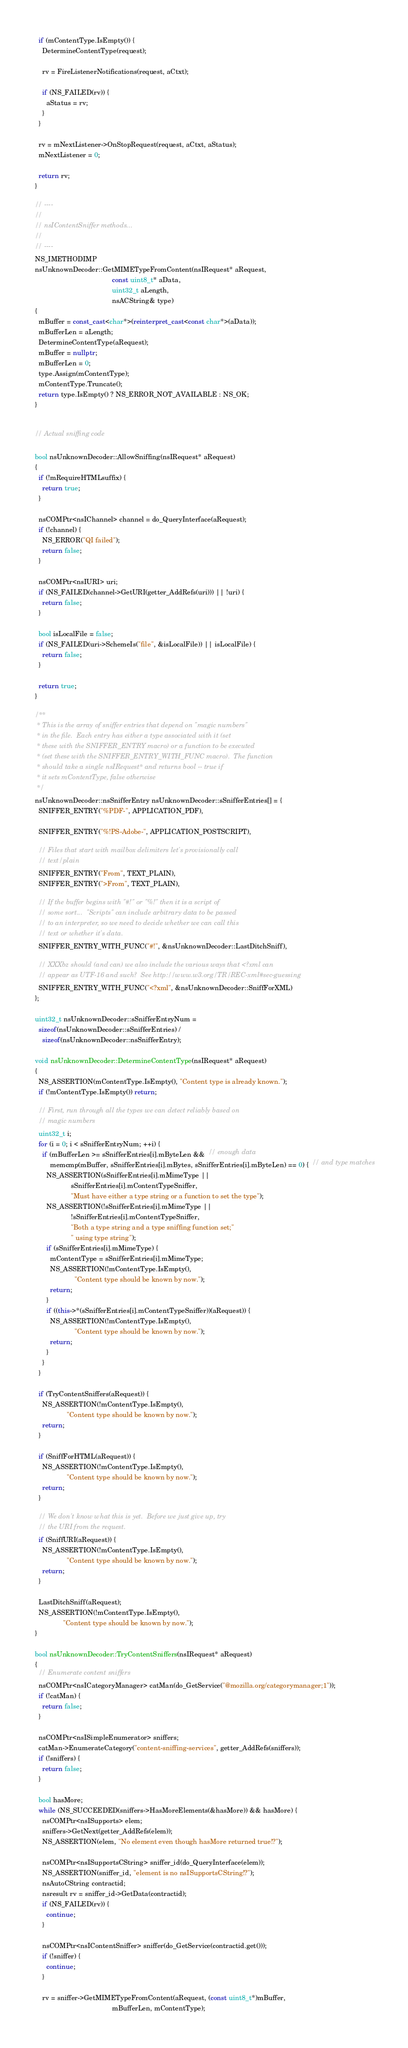<code> <loc_0><loc_0><loc_500><loc_500><_C++_>  if (mContentType.IsEmpty()) {
    DetermineContentType(request);

    rv = FireListenerNotifications(request, aCtxt);

    if (NS_FAILED(rv)) {
      aStatus = rv;
    }
  }

  rv = mNextListener->OnStopRequest(request, aCtxt, aStatus);
  mNextListener = 0;

  return rv;
}

// ----
//
// nsIContentSniffer methods...
//
// ----
NS_IMETHODIMP
nsUnknownDecoder::GetMIMETypeFromContent(nsIRequest* aRequest,
                                         const uint8_t* aData,
                                         uint32_t aLength,
                                         nsACString& type)
{
  mBuffer = const_cast<char*>(reinterpret_cast<const char*>(aData));
  mBufferLen = aLength;
  DetermineContentType(aRequest);
  mBuffer = nullptr;
  mBufferLen = 0;
  type.Assign(mContentType);
  mContentType.Truncate();
  return type.IsEmpty() ? NS_ERROR_NOT_AVAILABLE : NS_OK;
}


// Actual sniffing code

bool nsUnknownDecoder::AllowSniffing(nsIRequest* aRequest)
{
  if (!mRequireHTMLsuffix) {
    return true;
  }
  
  nsCOMPtr<nsIChannel> channel = do_QueryInterface(aRequest);
  if (!channel) {
    NS_ERROR("QI failed");
    return false;
  }

  nsCOMPtr<nsIURI> uri;
  if (NS_FAILED(channel->GetURI(getter_AddRefs(uri))) || !uri) {
    return false;
  }
  
  bool isLocalFile = false;
  if (NS_FAILED(uri->SchemeIs("file", &isLocalFile)) || isLocalFile) {
    return false;
  }

  return true;
}

/**
 * This is the array of sniffer entries that depend on "magic numbers"
 * in the file.  Each entry has either a type associated with it (set
 * these with the SNIFFER_ENTRY macro) or a function to be executed
 * (set these with the SNIFFER_ENTRY_WITH_FUNC macro).  The function
 * should take a single nsIRequest* and returns bool -- true if
 * it sets mContentType, false otherwise
 */
nsUnknownDecoder::nsSnifferEntry nsUnknownDecoder::sSnifferEntries[] = {
  SNIFFER_ENTRY("%PDF-", APPLICATION_PDF),

  SNIFFER_ENTRY("%!PS-Adobe-", APPLICATION_POSTSCRIPT),

  // Files that start with mailbox delimiters let's provisionally call
  // text/plain
  SNIFFER_ENTRY("From", TEXT_PLAIN),
  SNIFFER_ENTRY(">From", TEXT_PLAIN),

  // If the buffer begins with "#!" or "%!" then it is a script of
  // some sort...  "Scripts" can include arbitrary data to be passed
  // to an interpreter, so we need to decide whether we can call this
  // text or whether it's data.
  SNIFFER_ENTRY_WITH_FUNC("#!", &nsUnknownDecoder::LastDitchSniff),

  // XXXbz should (and can) we also include the various ways that <?xml can
  // appear as UTF-16 and such?  See http://www.w3.org/TR/REC-xml#sec-guessing
  SNIFFER_ENTRY_WITH_FUNC("<?xml", &nsUnknownDecoder::SniffForXML)
};

uint32_t nsUnknownDecoder::sSnifferEntryNum =
  sizeof(nsUnknownDecoder::sSnifferEntries) /
    sizeof(nsUnknownDecoder::nsSnifferEntry);

void nsUnknownDecoder::DetermineContentType(nsIRequest* aRequest)
{
  NS_ASSERTION(mContentType.IsEmpty(), "Content type is already known.");
  if (!mContentType.IsEmpty()) return;

  // First, run through all the types we can detect reliably based on
  // magic numbers
  uint32_t i;
  for (i = 0; i < sSnifferEntryNum; ++i) {
    if (mBufferLen >= sSnifferEntries[i].mByteLen &&  // enough data
        memcmp(mBuffer, sSnifferEntries[i].mBytes, sSnifferEntries[i].mByteLen) == 0) {  // and type matches
      NS_ASSERTION(sSnifferEntries[i].mMimeType ||
                   sSnifferEntries[i].mContentTypeSniffer,
                   "Must have either a type string or a function to set the type");
      NS_ASSERTION(!sSnifferEntries[i].mMimeType ||
                   !sSnifferEntries[i].mContentTypeSniffer,
                   "Both a type string and a type sniffing function set;"
                   " using type string");
      if (sSnifferEntries[i].mMimeType) {
        mContentType = sSnifferEntries[i].mMimeType;
        NS_ASSERTION(!mContentType.IsEmpty(), 
                     "Content type should be known by now.");
        return;
      }
      if ((this->*(sSnifferEntries[i].mContentTypeSniffer))(aRequest)) {
        NS_ASSERTION(!mContentType.IsEmpty(), 
                     "Content type should be known by now.");
        return;
      }        
    }
  }

  if (TryContentSniffers(aRequest)) {
    NS_ASSERTION(!mContentType.IsEmpty(), 
                 "Content type should be known by now.");
    return;
  }

  if (SniffForHTML(aRequest)) {
    NS_ASSERTION(!mContentType.IsEmpty(), 
                 "Content type should be known by now.");
    return;
  }
  
  // We don't know what this is yet.  Before we just give up, try
  // the URI from the request.
  if (SniffURI(aRequest)) {
    NS_ASSERTION(!mContentType.IsEmpty(), 
                 "Content type should be known by now.");
    return;
  }
  
  LastDitchSniff(aRequest);
  NS_ASSERTION(!mContentType.IsEmpty(), 
               "Content type should be known by now.");
}

bool nsUnknownDecoder::TryContentSniffers(nsIRequest* aRequest)
{
  // Enumerate content sniffers
  nsCOMPtr<nsICategoryManager> catMan(do_GetService("@mozilla.org/categorymanager;1"));
  if (!catMan) {
    return false;
  }

  nsCOMPtr<nsISimpleEnumerator> sniffers;
  catMan->EnumerateCategory("content-sniffing-services", getter_AddRefs(sniffers));
  if (!sniffers) {
    return false;
  }

  bool hasMore;
  while (NS_SUCCEEDED(sniffers->HasMoreElements(&hasMore)) && hasMore) {
    nsCOMPtr<nsISupports> elem;
    sniffers->GetNext(getter_AddRefs(elem));
    NS_ASSERTION(elem, "No element even though hasMore returned true!?");

    nsCOMPtr<nsISupportsCString> sniffer_id(do_QueryInterface(elem));
    NS_ASSERTION(sniffer_id, "element is no nsISupportsCString!?");
    nsAutoCString contractid;
    nsresult rv = sniffer_id->GetData(contractid);
    if (NS_FAILED(rv)) {
      continue;
    }

    nsCOMPtr<nsIContentSniffer> sniffer(do_GetService(contractid.get()));
    if (!sniffer) {
      continue;
    }

    rv = sniffer->GetMIMETypeFromContent(aRequest, (const uint8_t*)mBuffer,
                                         mBufferLen, mContentType);</code> 